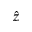<formula> <loc_0><loc_0><loc_500><loc_500>\hat { z }</formula> 